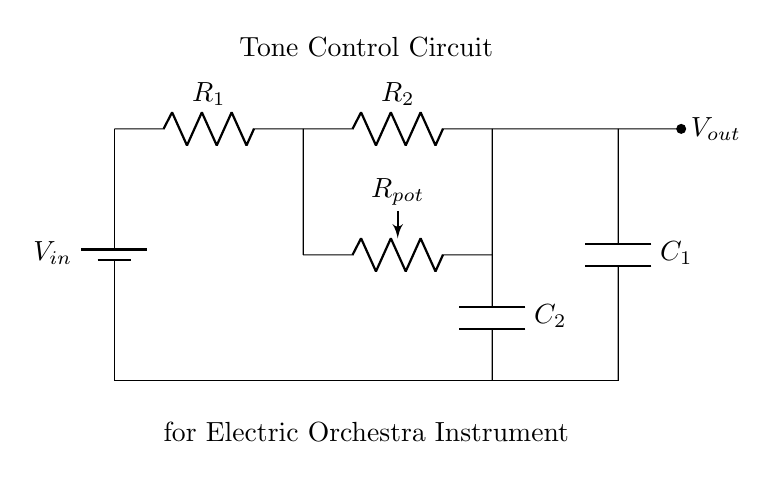What is the input voltage in this circuit? The input voltage is indicated as V_in, which serves as the voltage source for the circuit.
Answer: V_in What are the resistors in this circuit? The resistors in the circuit are R1, R2, and R_pot (the potentiometer), connected in series and parallel configurations.
Answer: R1, R2, R_pot What is the function of the capacitors in this circuit? The capacitors, C1 and C2, are used for tone control, filtering specific frequencies to shape the sound output.
Answer: Tone control How many capacitors are present in the circuit? There are two capacitors, C1 and C2, featured in the tone control circuit diagram.
Answer: 2 What happens when the potentiometer is adjusted? Adjusting the potentiometer, R_pot, changes the resistance in the circuit, altering the tone and frequency response of the sound.
Answer: Change tone Is this circuit a low-pass, high-pass, or band-pass filter? The configuration of this circuit suggests it acts as a low-pass filter, allowing lower frequencies to pass while attenuating higher frequencies.
Answer: Low-pass filter How does changing R1 affect the output voltage? Increasing R1 decreases the current flowing into the capacitors and affects the voltage division, resulting in a lower output voltage.
Answer: Decreases output voltage 